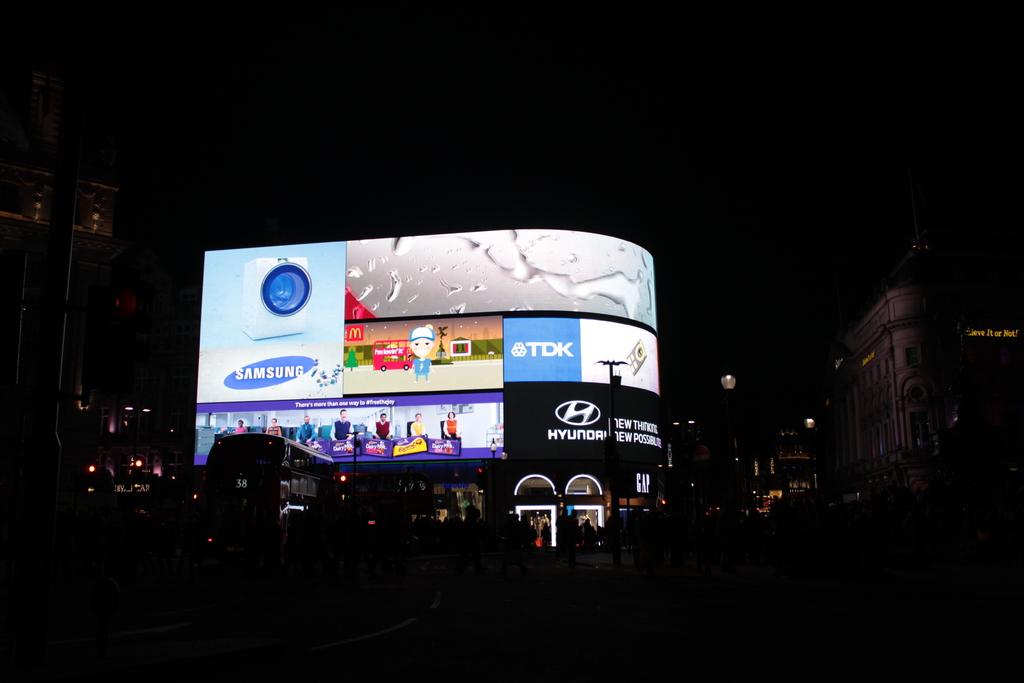What is the washing machine's brand?
Ensure brevity in your answer.  Samsung. What does the screen say?
Provide a short and direct response. Samsung. 